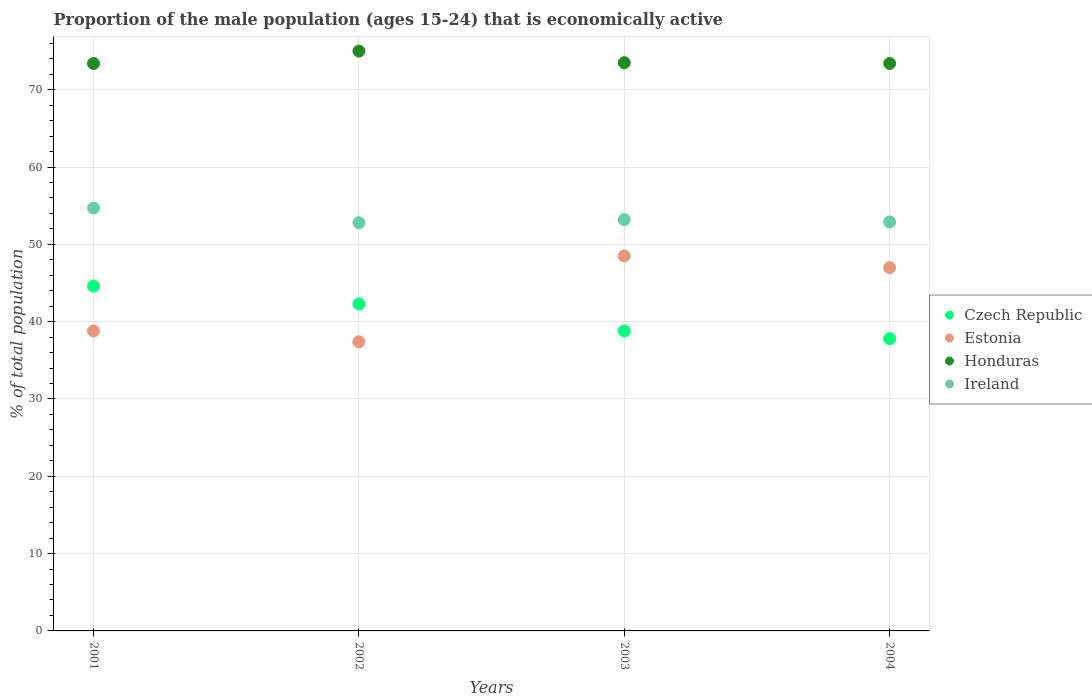How many different coloured dotlines are there?
Keep it short and to the point. 4. Is the number of dotlines equal to the number of legend labels?
Keep it short and to the point. Yes. What is the proportion of the male population that is economically active in Czech Republic in 2004?
Your answer should be compact. 37.8. Across all years, what is the maximum proportion of the male population that is economically active in Ireland?
Give a very brief answer. 54.7. Across all years, what is the minimum proportion of the male population that is economically active in Honduras?
Offer a very short reply. 73.4. What is the total proportion of the male population that is economically active in Czech Republic in the graph?
Keep it short and to the point. 163.5. What is the difference between the proportion of the male population that is economically active in Honduras in 2001 and that in 2004?
Keep it short and to the point. 0. What is the difference between the proportion of the male population that is economically active in Ireland in 2002 and the proportion of the male population that is economically active in Estonia in 2001?
Your response must be concise. 14. What is the average proportion of the male population that is economically active in Czech Republic per year?
Provide a succinct answer. 40.87. In the year 2003, what is the difference between the proportion of the male population that is economically active in Honduras and proportion of the male population that is economically active in Czech Republic?
Your response must be concise. 34.7. In how many years, is the proportion of the male population that is economically active in Ireland greater than 14 %?
Give a very brief answer. 4. What is the ratio of the proportion of the male population that is economically active in Estonia in 2001 to that in 2002?
Give a very brief answer. 1.04. What is the difference between the highest and the lowest proportion of the male population that is economically active in Czech Republic?
Your response must be concise. 6.8. Is the sum of the proportion of the male population that is economically active in Honduras in 2001 and 2002 greater than the maximum proportion of the male population that is economically active in Czech Republic across all years?
Give a very brief answer. Yes. Is it the case that in every year, the sum of the proportion of the male population that is economically active in Ireland and proportion of the male population that is economically active in Honduras  is greater than the sum of proportion of the male population that is economically active in Estonia and proportion of the male population that is economically active in Czech Republic?
Provide a short and direct response. Yes. Is it the case that in every year, the sum of the proportion of the male population that is economically active in Czech Republic and proportion of the male population that is economically active in Ireland  is greater than the proportion of the male population that is economically active in Estonia?
Provide a short and direct response. Yes. Does the proportion of the male population that is economically active in Ireland monotonically increase over the years?
Give a very brief answer. No. Is the proportion of the male population that is economically active in Ireland strictly less than the proportion of the male population that is economically active in Honduras over the years?
Your answer should be compact. Yes. What is the difference between two consecutive major ticks on the Y-axis?
Your answer should be very brief. 10. Does the graph contain grids?
Give a very brief answer. Yes. How many legend labels are there?
Keep it short and to the point. 4. What is the title of the graph?
Your answer should be very brief. Proportion of the male population (ages 15-24) that is economically active. What is the label or title of the Y-axis?
Ensure brevity in your answer.  % of total population. What is the % of total population in Czech Republic in 2001?
Give a very brief answer. 44.6. What is the % of total population in Estonia in 2001?
Offer a terse response. 38.8. What is the % of total population in Honduras in 2001?
Keep it short and to the point. 73.4. What is the % of total population of Ireland in 2001?
Provide a succinct answer. 54.7. What is the % of total population of Czech Republic in 2002?
Offer a very short reply. 42.3. What is the % of total population of Estonia in 2002?
Provide a succinct answer. 37.4. What is the % of total population of Honduras in 2002?
Make the answer very short. 75. What is the % of total population of Ireland in 2002?
Keep it short and to the point. 52.8. What is the % of total population of Czech Republic in 2003?
Offer a very short reply. 38.8. What is the % of total population in Estonia in 2003?
Make the answer very short. 48.5. What is the % of total population of Honduras in 2003?
Keep it short and to the point. 73.5. What is the % of total population in Ireland in 2003?
Your response must be concise. 53.2. What is the % of total population in Czech Republic in 2004?
Offer a very short reply. 37.8. What is the % of total population of Estonia in 2004?
Give a very brief answer. 47. What is the % of total population in Honduras in 2004?
Ensure brevity in your answer.  73.4. What is the % of total population of Ireland in 2004?
Make the answer very short. 52.9. Across all years, what is the maximum % of total population in Czech Republic?
Offer a very short reply. 44.6. Across all years, what is the maximum % of total population in Estonia?
Make the answer very short. 48.5. Across all years, what is the maximum % of total population of Honduras?
Give a very brief answer. 75. Across all years, what is the maximum % of total population in Ireland?
Offer a very short reply. 54.7. Across all years, what is the minimum % of total population in Czech Republic?
Ensure brevity in your answer.  37.8. Across all years, what is the minimum % of total population in Estonia?
Offer a terse response. 37.4. Across all years, what is the minimum % of total population in Honduras?
Make the answer very short. 73.4. Across all years, what is the minimum % of total population of Ireland?
Your response must be concise. 52.8. What is the total % of total population of Czech Republic in the graph?
Offer a terse response. 163.5. What is the total % of total population in Estonia in the graph?
Ensure brevity in your answer.  171.7. What is the total % of total population in Honduras in the graph?
Provide a short and direct response. 295.3. What is the total % of total population of Ireland in the graph?
Your response must be concise. 213.6. What is the difference between the % of total population of Czech Republic in 2001 and that in 2002?
Your answer should be compact. 2.3. What is the difference between the % of total population of Czech Republic in 2001 and that in 2003?
Your response must be concise. 5.8. What is the difference between the % of total population in Honduras in 2001 and that in 2003?
Offer a very short reply. -0.1. What is the difference between the % of total population in Ireland in 2001 and that in 2003?
Your answer should be very brief. 1.5. What is the difference between the % of total population in Czech Republic in 2001 and that in 2004?
Your response must be concise. 6.8. What is the difference between the % of total population of Ireland in 2001 and that in 2004?
Provide a short and direct response. 1.8. What is the difference between the % of total population in Czech Republic in 2002 and that in 2003?
Give a very brief answer. 3.5. What is the difference between the % of total population in Estonia in 2002 and that in 2003?
Your response must be concise. -11.1. What is the difference between the % of total population of Ireland in 2002 and that in 2003?
Offer a very short reply. -0.4. What is the difference between the % of total population in Czech Republic in 2002 and that in 2004?
Provide a succinct answer. 4.5. What is the difference between the % of total population of Estonia in 2002 and that in 2004?
Ensure brevity in your answer.  -9.6. What is the difference between the % of total population in Czech Republic in 2003 and that in 2004?
Ensure brevity in your answer.  1. What is the difference between the % of total population of Estonia in 2003 and that in 2004?
Keep it short and to the point. 1.5. What is the difference between the % of total population in Ireland in 2003 and that in 2004?
Your answer should be compact. 0.3. What is the difference between the % of total population in Czech Republic in 2001 and the % of total population in Honduras in 2002?
Offer a very short reply. -30.4. What is the difference between the % of total population of Estonia in 2001 and the % of total population of Honduras in 2002?
Your answer should be very brief. -36.2. What is the difference between the % of total population of Honduras in 2001 and the % of total population of Ireland in 2002?
Make the answer very short. 20.6. What is the difference between the % of total population in Czech Republic in 2001 and the % of total population in Estonia in 2003?
Your answer should be compact. -3.9. What is the difference between the % of total population of Czech Republic in 2001 and the % of total population of Honduras in 2003?
Your answer should be very brief. -28.9. What is the difference between the % of total population in Estonia in 2001 and the % of total population in Honduras in 2003?
Provide a short and direct response. -34.7. What is the difference between the % of total population in Estonia in 2001 and the % of total population in Ireland in 2003?
Your answer should be very brief. -14.4. What is the difference between the % of total population in Honduras in 2001 and the % of total population in Ireland in 2003?
Offer a terse response. 20.2. What is the difference between the % of total population of Czech Republic in 2001 and the % of total population of Honduras in 2004?
Your answer should be compact. -28.8. What is the difference between the % of total population in Estonia in 2001 and the % of total population in Honduras in 2004?
Offer a very short reply. -34.6. What is the difference between the % of total population of Estonia in 2001 and the % of total population of Ireland in 2004?
Give a very brief answer. -14.1. What is the difference between the % of total population in Czech Republic in 2002 and the % of total population in Honduras in 2003?
Give a very brief answer. -31.2. What is the difference between the % of total population in Estonia in 2002 and the % of total population in Honduras in 2003?
Offer a very short reply. -36.1. What is the difference between the % of total population of Estonia in 2002 and the % of total population of Ireland in 2003?
Make the answer very short. -15.8. What is the difference between the % of total population of Honduras in 2002 and the % of total population of Ireland in 2003?
Provide a short and direct response. 21.8. What is the difference between the % of total population of Czech Republic in 2002 and the % of total population of Estonia in 2004?
Your answer should be compact. -4.7. What is the difference between the % of total population of Czech Republic in 2002 and the % of total population of Honduras in 2004?
Your response must be concise. -31.1. What is the difference between the % of total population of Estonia in 2002 and the % of total population of Honduras in 2004?
Your answer should be compact. -36. What is the difference between the % of total population of Estonia in 2002 and the % of total population of Ireland in 2004?
Offer a very short reply. -15.5. What is the difference between the % of total population in Honduras in 2002 and the % of total population in Ireland in 2004?
Keep it short and to the point. 22.1. What is the difference between the % of total population in Czech Republic in 2003 and the % of total population in Honduras in 2004?
Offer a very short reply. -34.6. What is the difference between the % of total population in Czech Republic in 2003 and the % of total population in Ireland in 2004?
Your answer should be very brief. -14.1. What is the difference between the % of total population of Estonia in 2003 and the % of total population of Honduras in 2004?
Give a very brief answer. -24.9. What is the difference between the % of total population in Estonia in 2003 and the % of total population in Ireland in 2004?
Your response must be concise. -4.4. What is the difference between the % of total population of Honduras in 2003 and the % of total population of Ireland in 2004?
Offer a terse response. 20.6. What is the average % of total population of Czech Republic per year?
Ensure brevity in your answer.  40.88. What is the average % of total population in Estonia per year?
Your response must be concise. 42.92. What is the average % of total population in Honduras per year?
Your answer should be very brief. 73.83. What is the average % of total population in Ireland per year?
Keep it short and to the point. 53.4. In the year 2001, what is the difference between the % of total population in Czech Republic and % of total population in Honduras?
Your response must be concise. -28.8. In the year 2001, what is the difference between the % of total population in Estonia and % of total population in Honduras?
Your answer should be very brief. -34.6. In the year 2001, what is the difference between the % of total population in Estonia and % of total population in Ireland?
Ensure brevity in your answer.  -15.9. In the year 2002, what is the difference between the % of total population of Czech Republic and % of total population of Honduras?
Ensure brevity in your answer.  -32.7. In the year 2002, what is the difference between the % of total population in Czech Republic and % of total population in Ireland?
Keep it short and to the point. -10.5. In the year 2002, what is the difference between the % of total population in Estonia and % of total population in Honduras?
Your answer should be compact. -37.6. In the year 2002, what is the difference between the % of total population in Estonia and % of total population in Ireland?
Your response must be concise. -15.4. In the year 2002, what is the difference between the % of total population of Honduras and % of total population of Ireland?
Make the answer very short. 22.2. In the year 2003, what is the difference between the % of total population in Czech Republic and % of total population in Estonia?
Give a very brief answer. -9.7. In the year 2003, what is the difference between the % of total population of Czech Republic and % of total population of Honduras?
Keep it short and to the point. -34.7. In the year 2003, what is the difference between the % of total population in Czech Republic and % of total population in Ireland?
Offer a very short reply. -14.4. In the year 2003, what is the difference between the % of total population of Honduras and % of total population of Ireland?
Your response must be concise. 20.3. In the year 2004, what is the difference between the % of total population of Czech Republic and % of total population of Honduras?
Ensure brevity in your answer.  -35.6. In the year 2004, what is the difference between the % of total population of Czech Republic and % of total population of Ireland?
Provide a short and direct response. -15.1. In the year 2004, what is the difference between the % of total population of Estonia and % of total population of Honduras?
Your answer should be very brief. -26.4. What is the ratio of the % of total population in Czech Republic in 2001 to that in 2002?
Keep it short and to the point. 1.05. What is the ratio of the % of total population of Estonia in 2001 to that in 2002?
Your response must be concise. 1.04. What is the ratio of the % of total population of Honduras in 2001 to that in 2002?
Your answer should be very brief. 0.98. What is the ratio of the % of total population in Ireland in 2001 to that in 2002?
Ensure brevity in your answer.  1.04. What is the ratio of the % of total population of Czech Republic in 2001 to that in 2003?
Offer a terse response. 1.15. What is the ratio of the % of total population of Estonia in 2001 to that in 2003?
Give a very brief answer. 0.8. What is the ratio of the % of total population in Honduras in 2001 to that in 2003?
Ensure brevity in your answer.  1. What is the ratio of the % of total population in Ireland in 2001 to that in 2003?
Make the answer very short. 1.03. What is the ratio of the % of total population of Czech Republic in 2001 to that in 2004?
Provide a succinct answer. 1.18. What is the ratio of the % of total population of Estonia in 2001 to that in 2004?
Your answer should be very brief. 0.83. What is the ratio of the % of total population of Honduras in 2001 to that in 2004?
Offer a very short reply. 1. What is the ratio of the % of total population of Ireland in 2001 to that in 2004?
Provide a succinct answer. 1.03. What is the ratio of the % of total population of Czech Republic in 2002 to that in 2003?
Give a very brief answer. 1.09. What is the ratio of the % of total population of Estonia in 2002 to that in 2003?
Provide a succinct answer. 0.77. What is the ratio of the % of total population in Honduras in 2002 to that in 2003?
Offer a terse response. 1.02. What is the ratio of the % of total population in Ireland in 2002 to that in 2003?
Offer a very short reply. 0.99. What is the ratio of the % of total population of Czech Republic in 2002 to that in 2004?
Your answer should be very brief. 1.12. What is the ratio of the % of total population in Estonia in 2002 to that in 2004?
Provide a short and direct response. 0.8. What is the ratio of the % of total population in Honduras in 2002 to that in 2004?
Provide a short and direct response. 1.02. What is the ratio of the % of total population in Ireland in 2002 to that in 2004?
Provide a succinct answer. 1. What is the ratio of the % of total population of Czech Republic in 2003 to that in 2004?
Your answer should be compact. 1.03. What is the ratio of the % of total population of Estonia in 2003 to that in 2004?
Ensure brevity in your answer.  1.03. What is the ratio of the % of total population of Ireland in 2003 to that in 2004?
Give a very brief answer. 1.01. What is the difference between the highest and the second highest % of total population in Honduras?
Give a very brief answer. 1.5. What is the difference between the highest and the lowest % of total population in Czech Republic?
Ensure brevity in your answer.  6.8. What is the difference between the highest and the lowest % of total population in Ireland?
Provide a short and direct response. 1.9. 